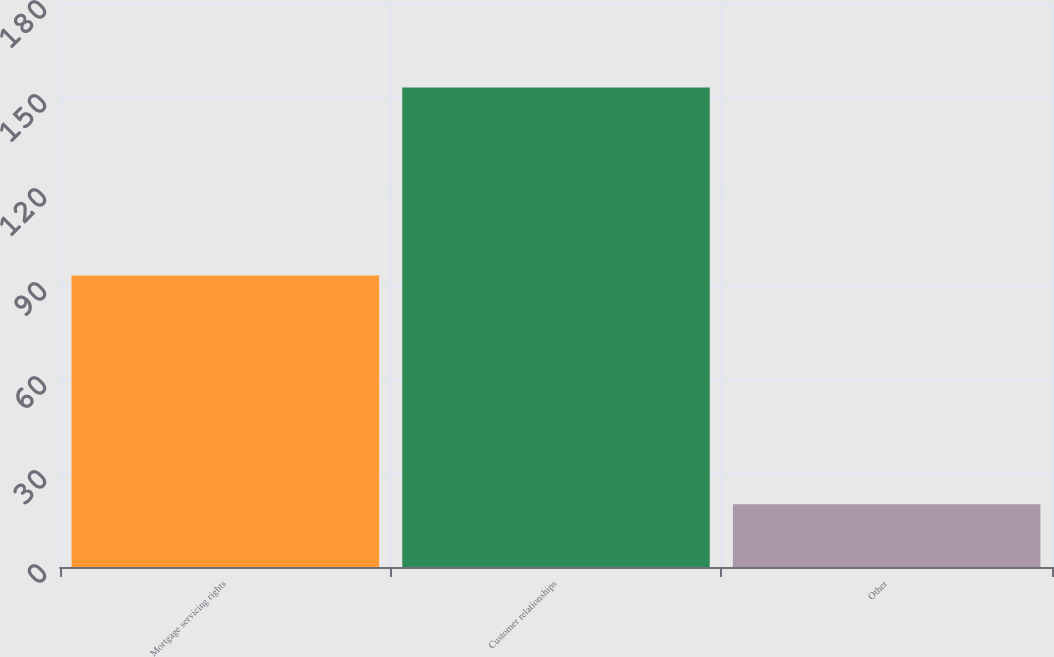<chart> <loc_0><loc_0><loc_500><loc_500><bar_chart><fcel>Mortgage servicing rights<fcel>Customer relationships<fcel>Other<nl><fcel>93<fcel>153<fcel>20<nl></chart> 